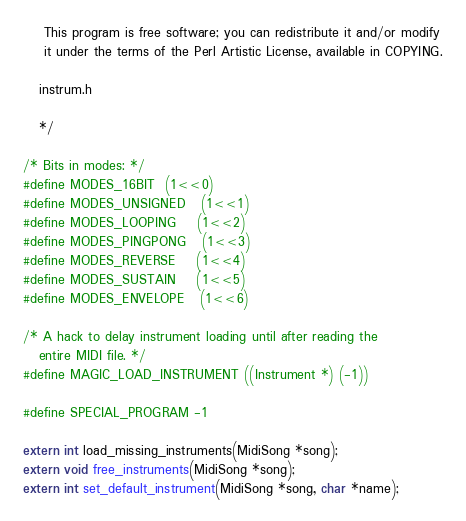<code> <loc_0><loc_0><loc_500><loc_500><_C_>
    This program is free software; you can redistribute it and/or modify
    it under the terms of the Perl Artistic License, available in COPYING.

   instrum.h

   */

/* Bits in modes: */
#define MODES_16BIT	(1<<0)
#define MODES_UNSIGNED	(1<<1)
#define MODES_LOOPING	(1<<2)
#define MODES_PINGPONG	(1<<3)
#define MODES_REVERSE	(1<<4)
#define MODES_SUSTAIN	(1<<5)
#define MODES_ENVELOPE	(1<<6)

/* A hack to delay instrument loading until after reading the
   entire MIDI file. */
#define MAGIC_LOAD_INSTRUMENT ((Instrument *) (-1))

#define SPECIAL_PROGRAM -1

extern int load_missing_instruments(MidiSong *song);
extern void free_instruments(MidiSong *song);
extern int set_default_instrument(MidiSong *song, char *name);
</code> 